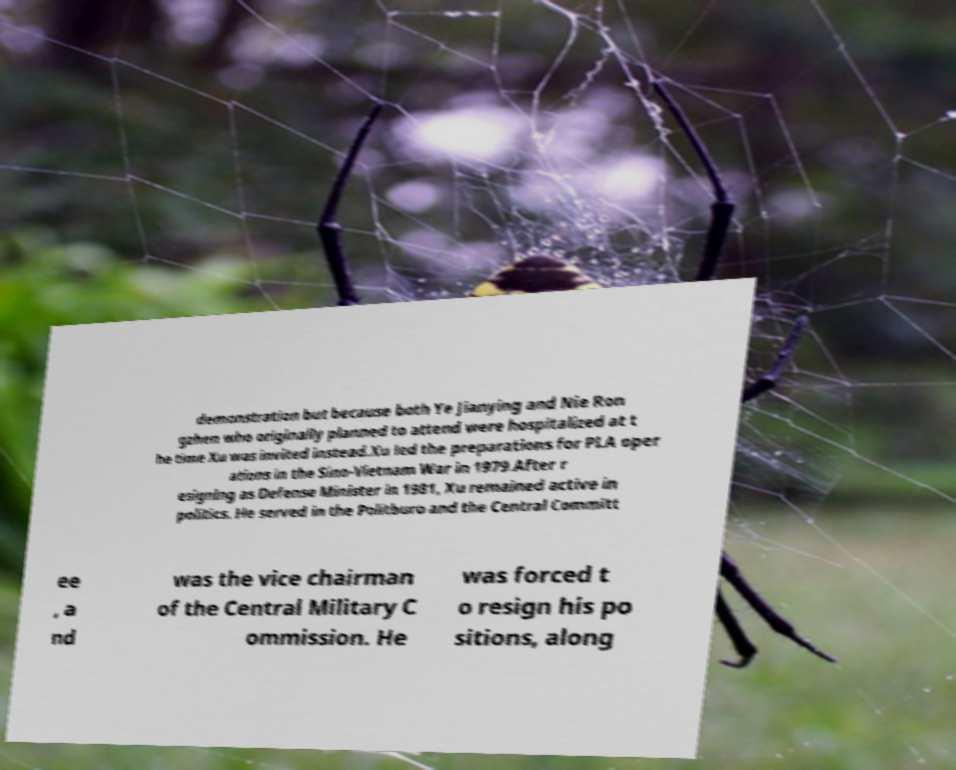Can you accurately transcribe the text from the provided image for me? demonstration but because both Ye Jianying and Nie Ron gzhen who originally planned to attend were hospitalized at t he time Xu was invited instead.Xu led the preparations for PLA oper ations in the Sino-Vietnam War in 1979.After r esigning as Defense Minister in 1981, Xu remained active in politics. He served in the Politburo and the Central Committ ee , a nd was the vice chairman of the Central Military C ommission. He was forced t o resign his po sitions, along 